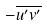<formula> <loc_0><loc_0><loc_500><loc_500>- \overline { u ^ { \prime } v ^ { \prime } }</formula> 